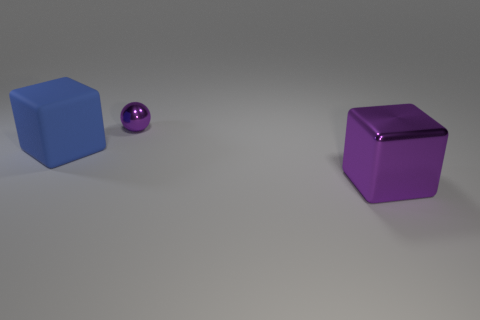Is there anything else that has the same material as the blue object?
Offer a very short reply. No. Is there any other thing that has the same size as the metal sphere?
Offer a very short reply. No. There is a object that is to the right of the blue matte object and on the left side of the purple shiny cube; what is its color?
Offer a terse response. Purple. How many small purple shiny spheres are there?
Your response must be concise. 1. Do the blue rubber block and the metal cube have the same size?
Ensure brevity in your answer.  Yes. Is there a small object of the same color as the metallic sphere?
Make the answer very short. No. Does the metallic thing in front of the big blue matte thing have the same shape as the rubber object?
Make the answer very short. Yes. How many blue matte things are the same size as the metallic block?
Give a very brief answer. 1. There is a object to the right of the ball; how many small spheres are in front of it?
Provide a succinct answer. 0. Are the purple thing to the right of the purple ball and the sphere made of the same material?
Provide a succinct answer. Yes. 